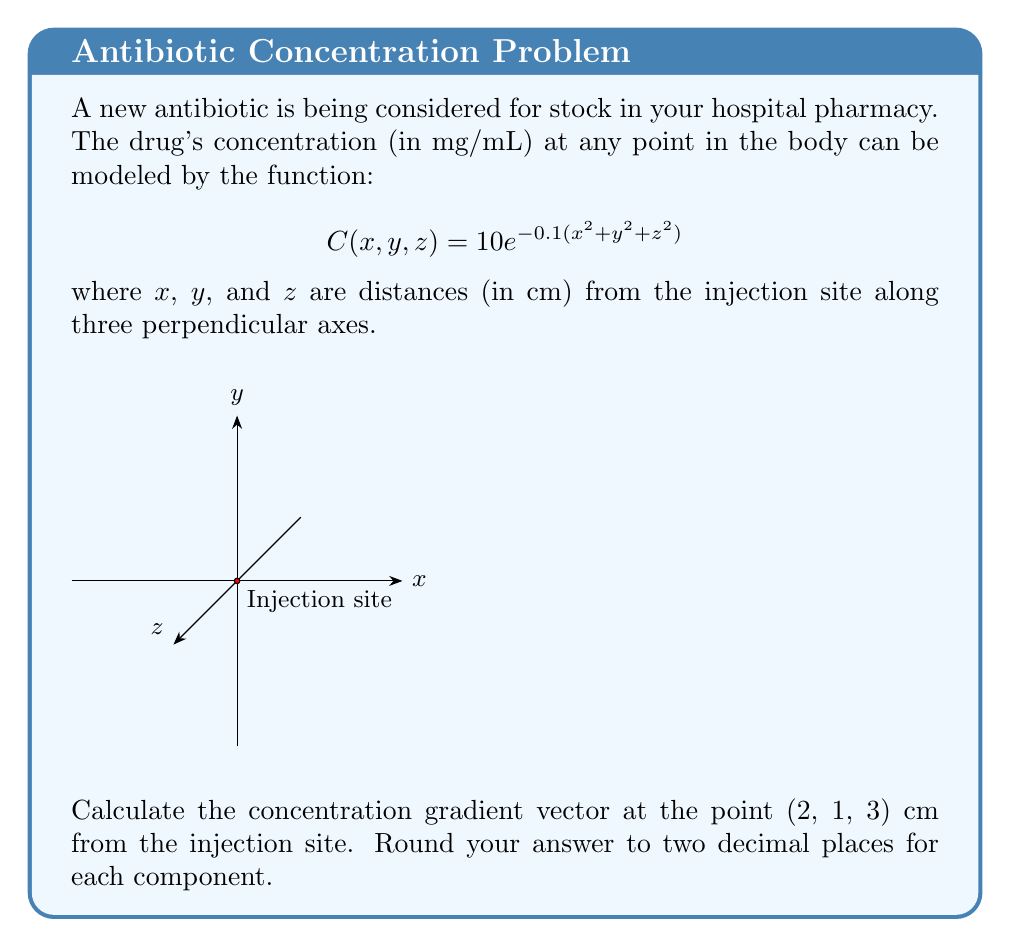What is the answer to this math problem? To solve this problem, we need to follow these steps:

1) The concentration gradient is given by the partial derivatives of C with respect to x, y, and z:

   $$\nabla C = \left(\frac{\partial C}{\partial x}, \frac{\partial C}{\partial y}, \frac{\partial C}{\partial z}\right)$$

2) Let's calculate each partial derivative:

   $$\frac{\partial C}{\partial x} = 10e^{-0.1(x^2 + y^2 + z^2)} \cdot (-0.2x)$$
   $$\frac{\partial C}{\partial y} = 10e^{-0.1(x^2 + y^2 + z^2)} \cdot (-0.2y)$$
   $$\frac{\partial C}{\partial z} = 10e^{-0.1(x^2 + y^2 + z^2)} \cdot (-0.2z)$$

3) Now, we need to evaluate these at the point (2, 1, 3):

   First, let's calculate the exponential term:
   $$e^{-0.1(2^2 + 1^2 + 3^2)} = e^{-0.1(4 + 1 + 9)} = e^{-1.4} \approx 0.2466$$

   Now, let's calculate each component:

   $$\frac{\partial C}{\partial x} = 10 \cdot 0.2466 \cdot (-0.2 \cdot 2) = -0.9864$$
   $$\frac{\partial C}{\partial y} = 10 \cdot 0.2466 \cdot (-0.2 \cdot 1) = -0.4932$$
   $$\frac{\partial C}{\partial z} = 10 \cdot 0.2466 \cdot (-0.2 \cdot 3) = -1.4796$$

4) Therefore, the concentration gradient vector is approximately:
   $$\nabla C \approx (-0.99, -0.49, -1.48)$$

   Rounding to two decimal places for each component.
Answer: $(-0.99, -0.49, -1.48)$ 